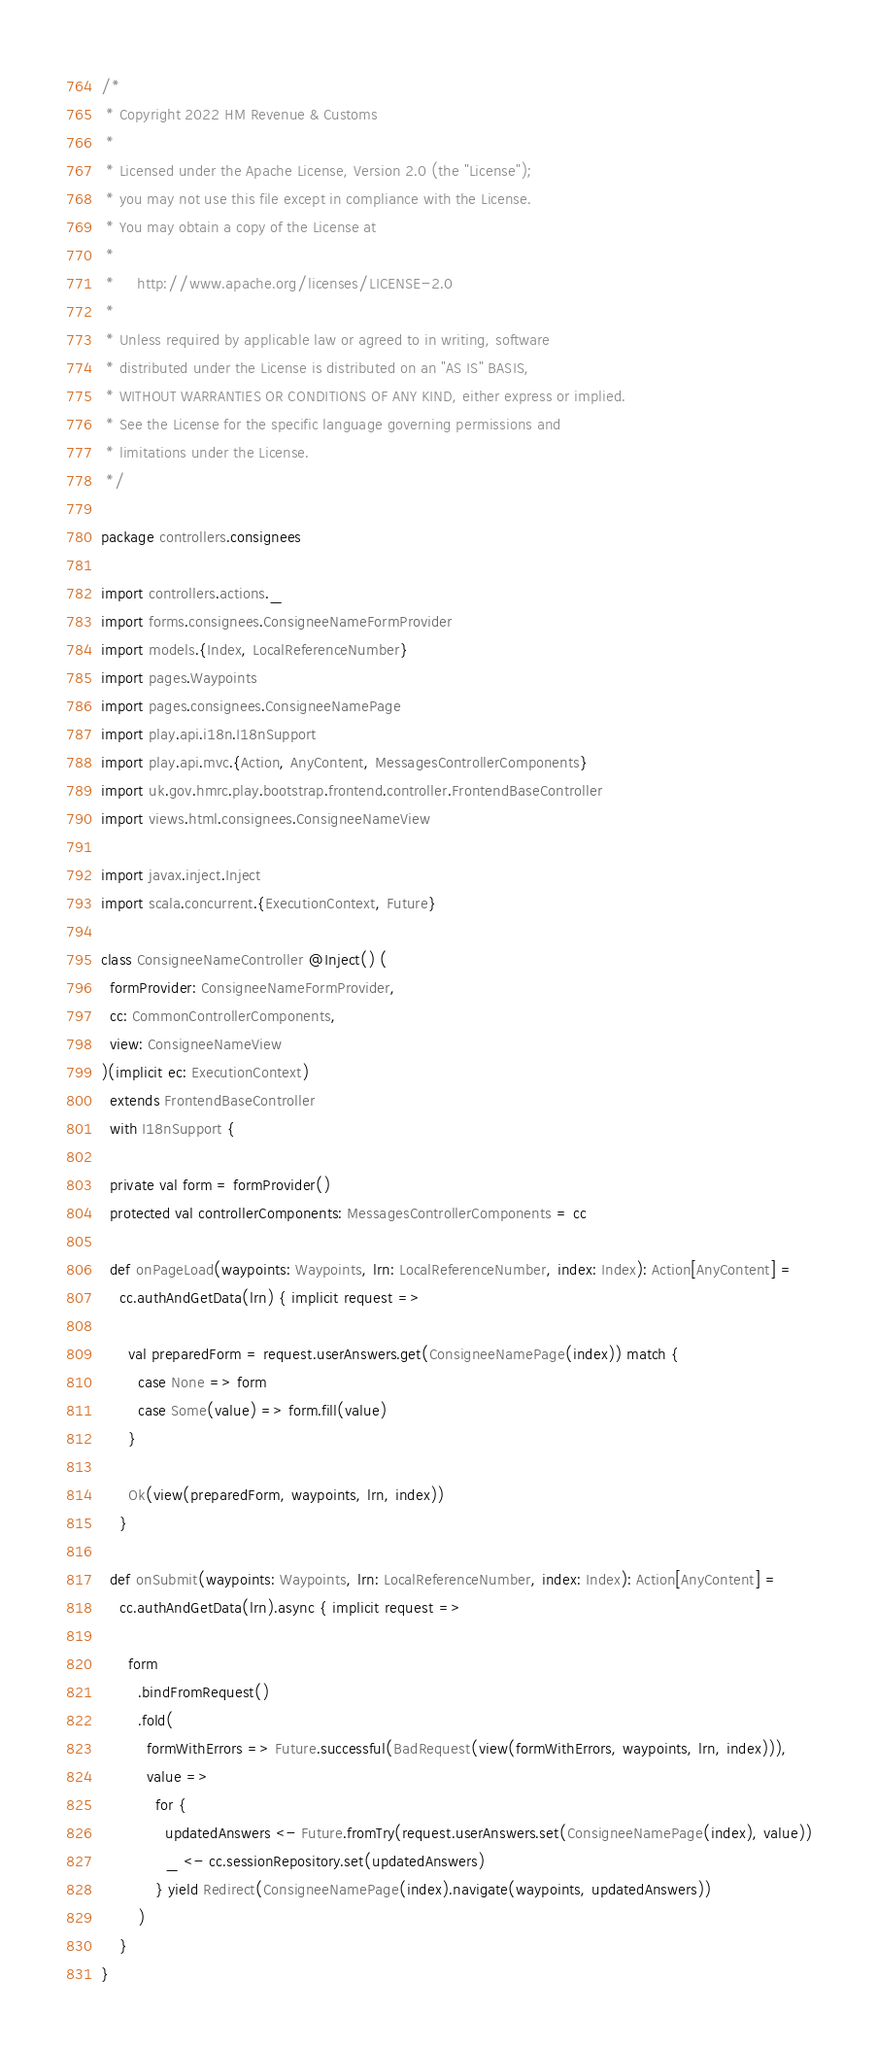Convert code to text. <code><loc_0><loc_0><loc_500><loc_500><_Scala_>/*
 * Copyright 2022 HM Revenue & Customs
 *
 * Licensed under the Apache License, Version 2.0 (the "License");
 * you may not use this file except in compliance with the License.
 * You may obtain a copy of the License at
 *
 *     http://www.apache.org/licenses/LICENSE-2.0
 *
 * Unless required by applicable law or agreed to in writing, software
 * distributed under the License is distributed on an "AS IS" BASIS,
 * WITHOUT WARRANTIES OR CONDITIONS OF ANY KIND, either express or implied.
 * See the License for the specific language governing permissions and
 * limitations under the License.
 */

package controllers.consignees

import controllers.actions._
import forms.consignees.ConsigneeNameFormProvider
import models.{Index, LocalReferenceNumber}
import pages.Waypoints
import pages.consignees.ConsigneeNamePage
import play.api.i18n.I18nSupport
import play.api.mvc.{Action, AnyContent, MessagesControllerComponents}
import uk.gov.hmrc.play.bootstrap.frontend.controller.FrontendBaseController
import views.html.consignees.ConsigneeNameView

import javax.inject.Inject
import scala.concurrent.{ExecutionContext, Future}

class ConsigneeNameController @Inject() (
  formProvider: ConsigneeNameFormProvider,
  cc: CommonControllerComponents,
  view: ConsigneeNameView
)(implicit ec: ExecutionContext)
  extends FrontendBaseController
  with I18nSupport {

  private val form = formProvider()
  protected val controllerComponents: MessagesControllerComponents = cc

  def onPageLoad(waypoints: Waypoints, lrn: LocalReferenceNumber, index: Index): Action[AnyContent] =
    cc.authAndGetData(lrn) { implicit request =>

      val preparedForm = request.userAnswers.get(ConsigneeNamePage(index)) match {
        case None => form
        case Some(value) => form.fill(value)
      }

      Ok(view(preparedForm, waypoints, lrn, index))
    }

  def onSubmit(waypoints: Waypoints, lrn: LocalReferenceNumber, index: Index): Action[AnyContent] =
    cc.authAndGetData(lrn).async { implicit request =>

      form
        .bindFromRequest()
        .fold(
          formWithErrors => Future.successful(BadRequest(view(formWithErrors, waypoints, lrn, index))),
          value =>
            for {
              updatedAnswers <- Future.fromTry(request.userAnswers.set(ConsigneeNamePage(index), value))
              _ <- cc.sessionRepository.set(updatedAnswers)
            } yield Redirect(ConsigneeNamePage(index).navigate(waypoints, updatedAnswers))
        )
    }
}
</code> 